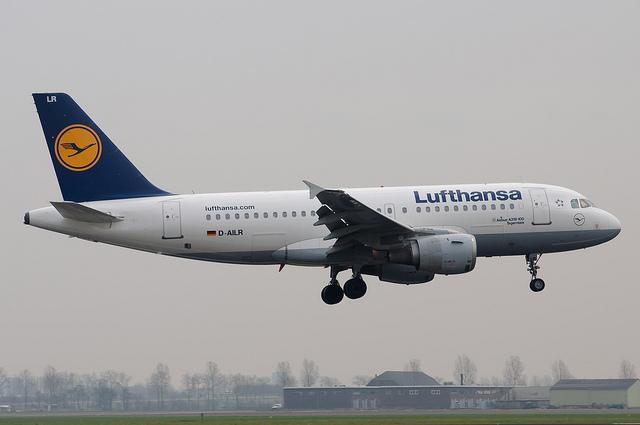How many elephants are in the picture?
Give a very brief answer. 0. 